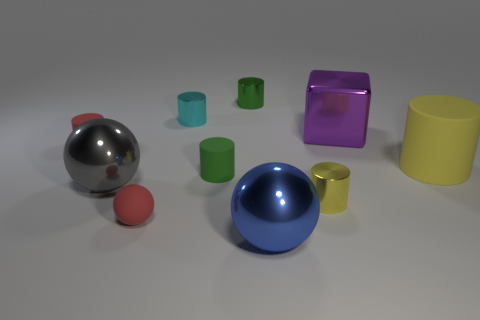Subtract 0 blue cylinders. How many objects are left? 10 Subtract all cubes. How many objects are left? 9 Subtract 1 cubes. How many cubes are left? 0 Subtract all green cubes. Subtract all cyan spheres. How many cubes are left? 1 Subtract all yellow spheres. How many yellow cylinders are left? 2 Subtract all small blue cylinders. Subtract all small red cylinders. How many objects are left? 9 Add 7 big balls. How many big balls are left? 9 Add 8 big purple shiny spheres. How many big purple shiny spheres exist? 8 Subtract all gray spheres. How many spheres are left? 2 Subtract all tiny green rubber cylinders. How many cylinders are left? 5 